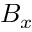Convert formula to latex. <formula><loc_0><loc_0><loc_500><loc_500>B _ { x }</formula> 